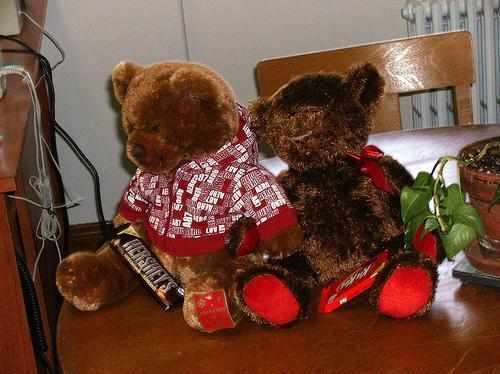How many bears are there?
Give a very brief answer. 2. How many bears are in this picture?
Give a very brief answer. 2. How many candy bars are in the picture?
Give a very brief answer. 2. How many flowers are in the pot?
Give a very brief answer. 1. How many bears are furry?
Give a very brief answer. 2. 